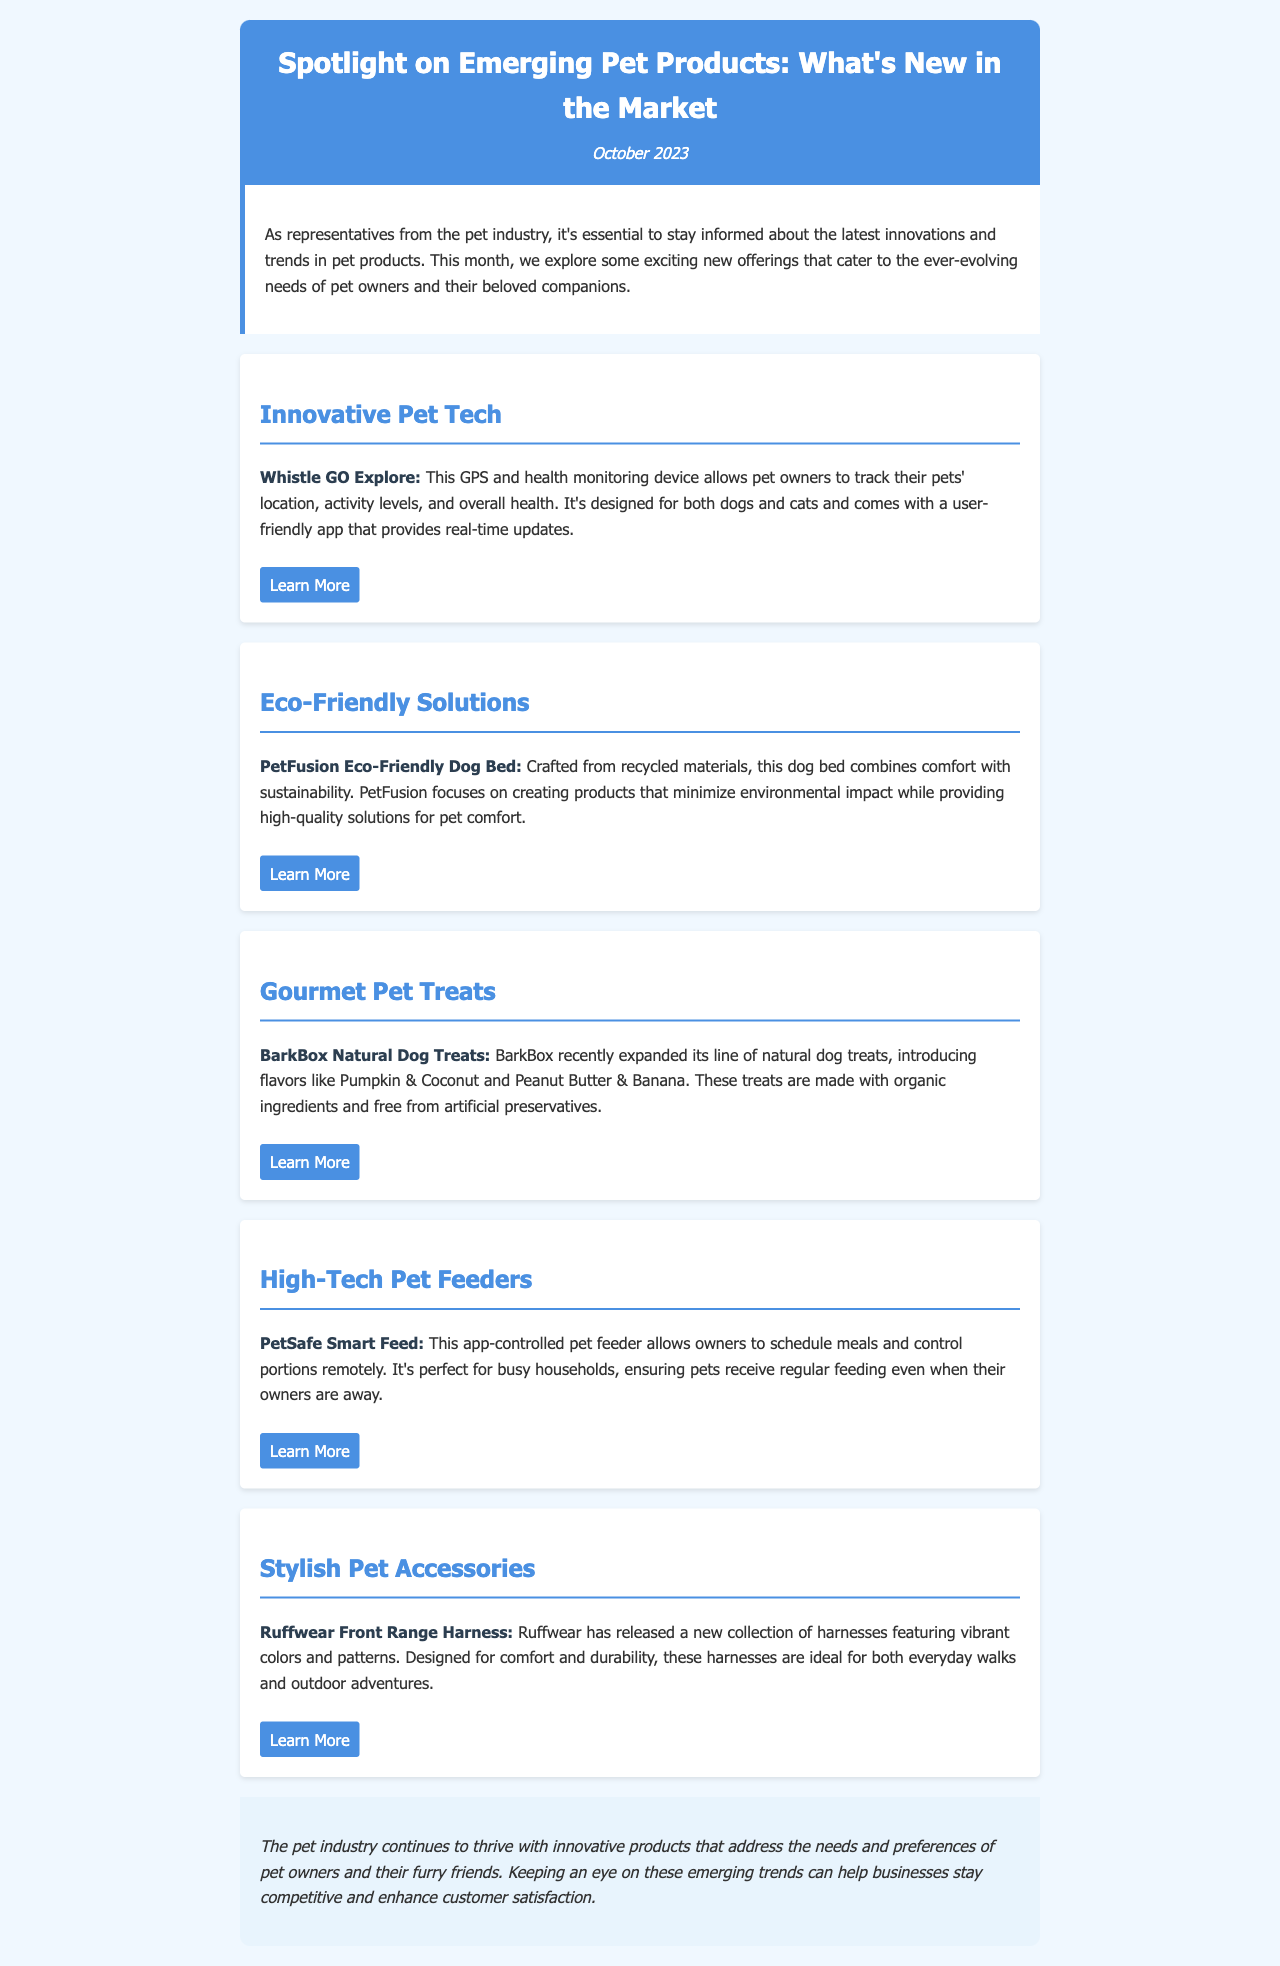what is the title of the newsletter? The title of the newsletter is prominently displayed at the top, stating "Spotlight on Emerging Pet Products: What's New in the Market."
Answer: Spotlight on Emerging Pet Products: What's New in the Market what is the date of publication? The date of publication is indicated below the title in the header section.
Answer: October 2023 which product focuses on pet health tracking? The document mentions a specific product that allows tracking of pets' location and health, categorized under "Innovative Pet Tech."
Answer: Whistle GO Explore what is the main material used in the PetFusion Eco-Friendly Dog Bed? The material used in the PetFusion Eco-Friendly Dog Bed is described explicitly in the Eco-Friendly Solutions section.
Answer: recycled materials what flavor is NOT included in the BarkBox Natural Dog Treats? The flavors mentioned in the Gourmet Pet Treats section include specific examples, and a flavor not listed would answer this question.
Answer: Not specified (any flavor other than Pumpkin & Coconut or Peanut Butter & Banana) which section discusses a product designed for busy households? The section related to busy households specifically addresses a product that aids in meal scheduling.
Answer: High-Tech Pet Feeders how does the Ruffwear Front Range Harness stand out? The design attributes of the Ruffwear Front Range Harness are highlighted in the Stylish Pet Accessories section.
Answer: vibrant colors and patterns what type of content is primarily featured in this newsletter? The main focus of the newsletter is about new pet products and their features, as outlined early in the document.
Answer: emerging pet products 